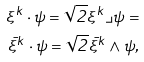<formula> <loc_0><loc_0><loc_500><loc_500>\xi ^ { k } \cdot \psi = \sqrt { 2 } \xi ^ { k } \lrcorner \psi = \\ \bar { \xi } ^ { k } \cdot \psi = \sqrt { 2 } \bar { \xi } ^ { k } \wedge \psi ,</formula> 